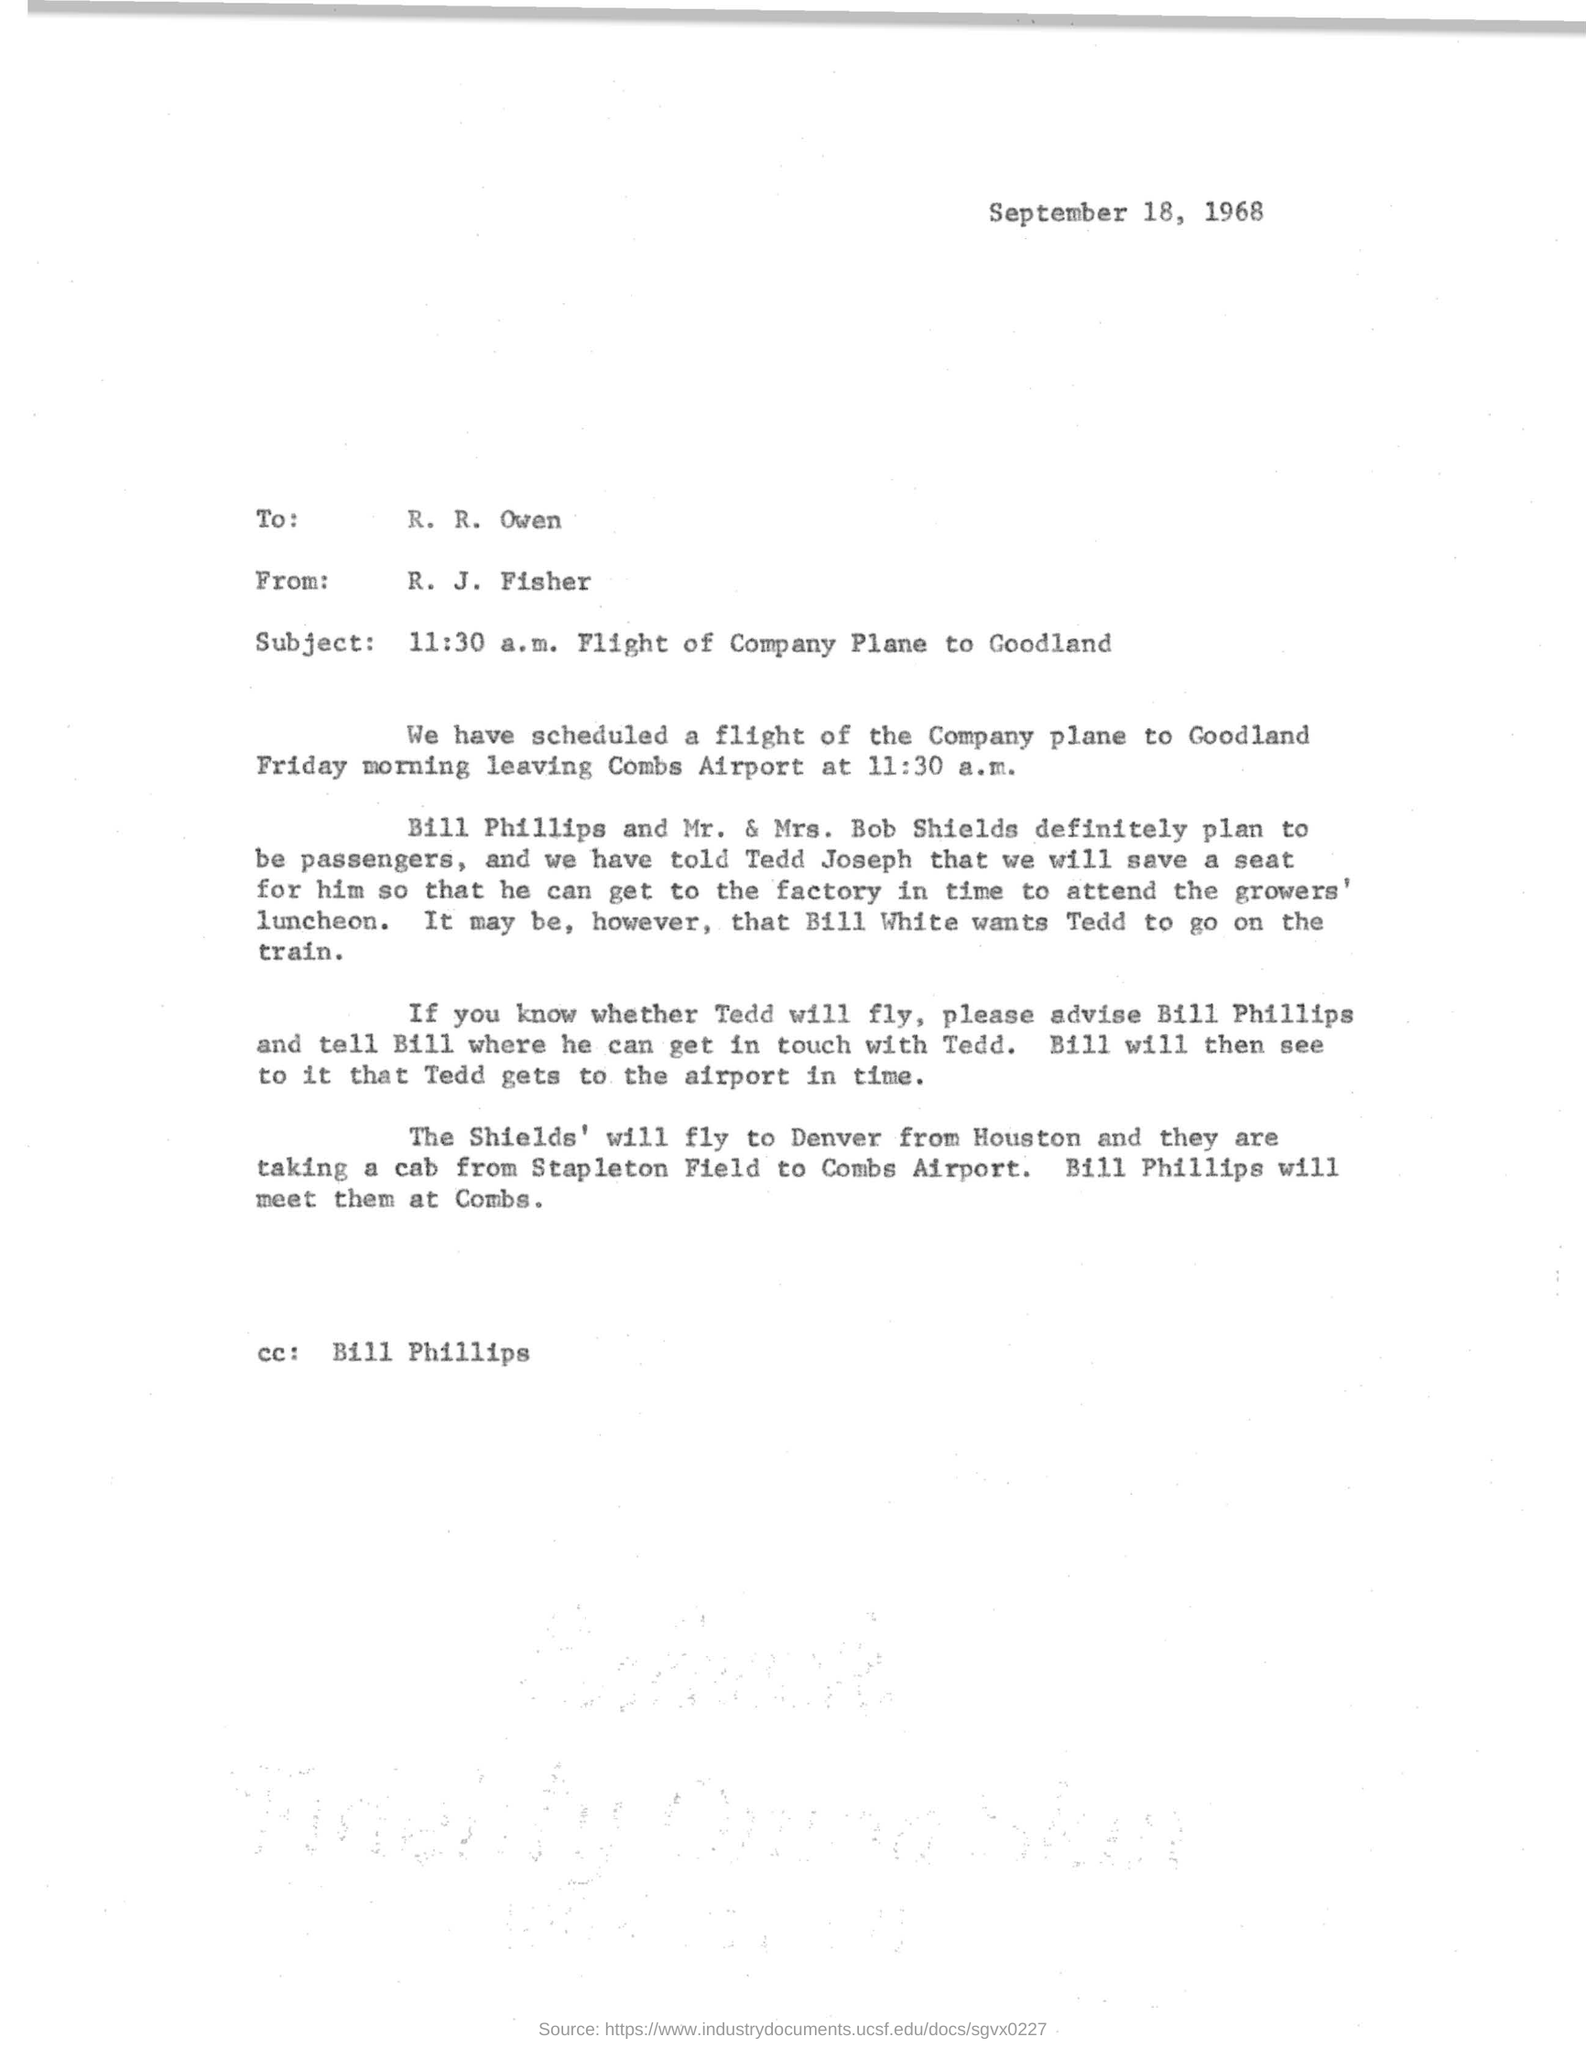Who is the sender of the letter?
Your response must be concise. R. J. Fisher. Where is the flight destination?
Give a very brief answer. Goodland. From which airport is the flight scheduled?
Provide a succinct answer. Combs Airport. Which function has to be attended by Tedd Joseph?
Provide a succinct answer. Growers' luncheon. At what time is the flight scheduled?
Keep it short and to the point. 11:30 a.m. 